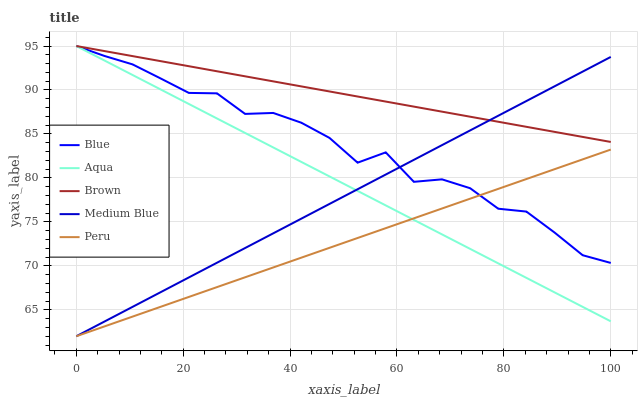Does Peru have the minimum area under the curve?
Answer yes or no. Yes. Does Brown have the maximum area under the curve?
Answer yes or no. Yes. Does Aqua have the minimum area under the curve?
Answer yes or no. No. Does Aqua have the maximum area under the curve?
Answer yes or no. No. Is Peru the smoothest?
Answer yes or no. Yes. Is Blue the roughest?
Answer yes or no. Yes. Is Brown the smoothest?
Answer yes or no. No. Is Brown the roughest?
Answer yes or no. No. Does Medium Blue have the lowest value?
Answer yes or no. Yes. Does Aqua have the lowest value?
Answer yes or no. No. Does Aqua have the highest value?
Answer yes or no. Yes. Does Medium Blue have the highest value?
Answer yes or no. No. Is Peru less than Brown?
Answer yes or no. Yes. Is Brown greater than Peru?
Answer yes or no. Yes. Does Medium Blue intersect Brown?
Answer yes or no. Yes. Is Medium Blue less than Brown?
Answer yes or no. No. Is Medium Blue greater than Brown?
Answer yes or no. No. Does Peru intersect Brown?
Answer yes or no. No. 